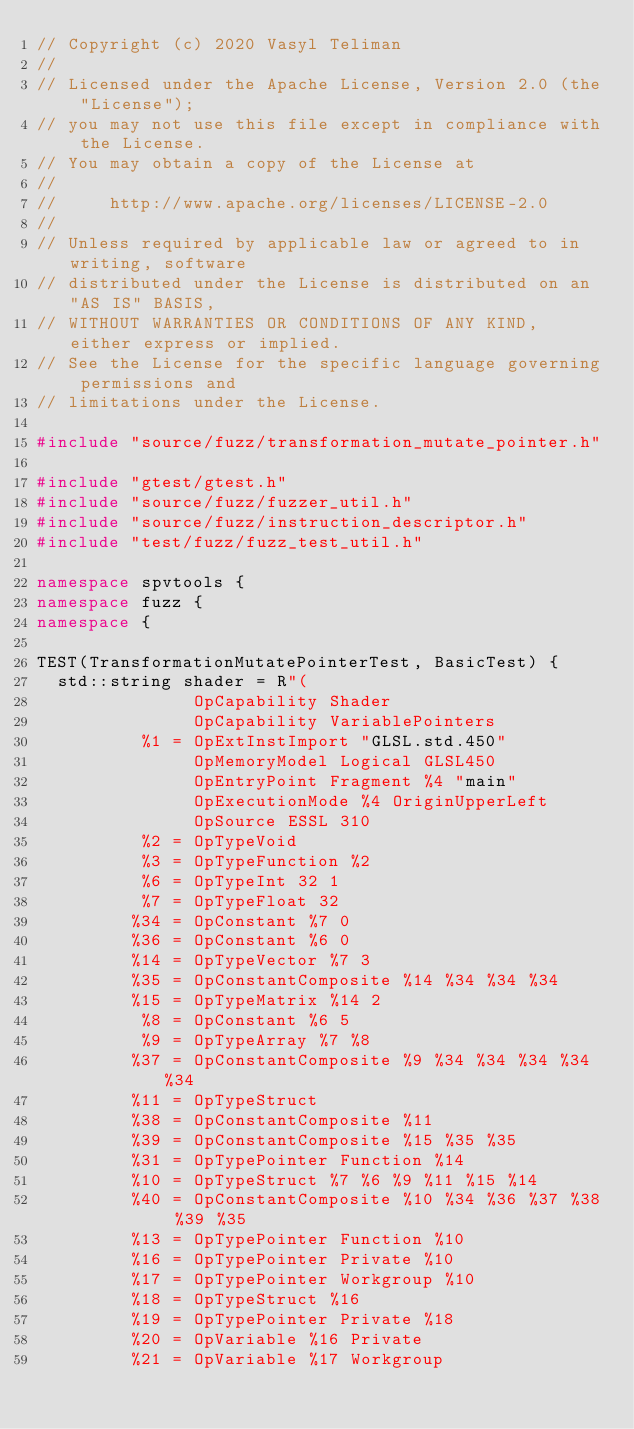Convert code to text. <code><loc_0><loc_0><loc_500><loc_500><_C++_>// Copyright (c) 2020 Vasyl Teliman
//
// Licensed under the Apache License, Version 2.0 (the "License");
// you may not use this file except in compliance with the License.
// You may obtain a copy of the License at
//
//     http://www.apache.org/licenses/LICENSE-2.0
//
// Unless required by applicable law or agreed to in writing, software
// distributed under the License is distributed on an "AS IS" BASIS,
// WITHOUT WARRANTIES OR CONDITIONS OF ANY KIND, either express or implied.
// See the License for the specific language governing permissions and
// limitations under the License.

#include "source/fuzz/transformation_mutate_pointer.h"

#include "gtest/gtest.h"
#include "source/fuzz/fuzzer_util.h"
#include "source/fuzz/instruction_descriptor.h"
#include "test/fuzz/fuzz_test_util.h"

namespace spvtools {
namespace fuzz {
namespace {

TEST(TransformationMutatePointerTest, BasicTest) {
  std::string shader = R"(
               OpCapability Shader
               OpCapability VariablePointers
          %1 = OpExtInstImport "GLSL.std.450"
               OpMemoryModel Logical GLSL450
               OpEntryPoint Fragment %4 "main"
               OpExecutionMode %4 OriginUpperLeft
               OpSource ESSL 310
          %2 = OpTypeVoid
          %3 = OpTypeFunction %2
          %6 = OpTypeInt 32 1
          %7 = OpTypeFloat 32
         %34 = OpConstant %7 0
         %36 = OpConstant %6 0
         %14 = OpTypeVector %7 3
         %35 = OpConstantComposite %14 %34 %34 %34
         %15 = OpTypeMatrix %14 2
          %8 = OpConstant %6 5
          %9 = OpTypeArray %7 %8
         %37 = OpConstantComposite %9 %34 %34 %34 %34 %34
         %11 = OpTypeStruct
         %38 = OpConstantComposite %11
         %39 = OpConstantComposite %15 %35 %35
         %31 = OpTypePointer Function %14
         %10 = OpTypeStruct %7 %6 %9 %11 %15 %14
         %40 = OpConstantComposite %10 %34 %36 %37 %38 %39 %35
         %13 = OpTypePointer Function %10
         %16 = OpTypePointer Private %10
         %17 = OpTypePointer Workgroup %10
         %18 = OpTypeStruct %16
         %19 = OpTypePointer Private %18
         %20 = OpVariable %16 Private
         %21 = OpVariable %17 Workgroup</code> 